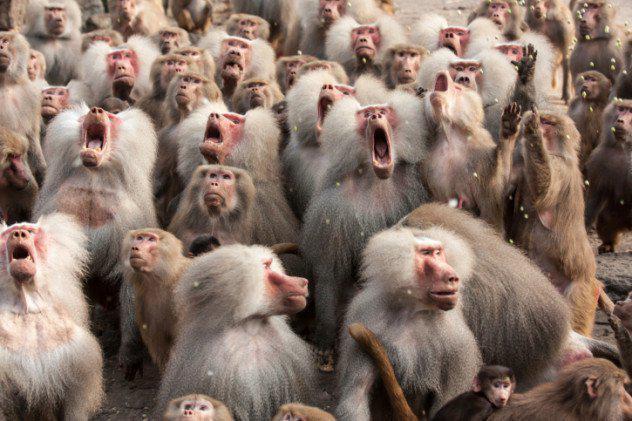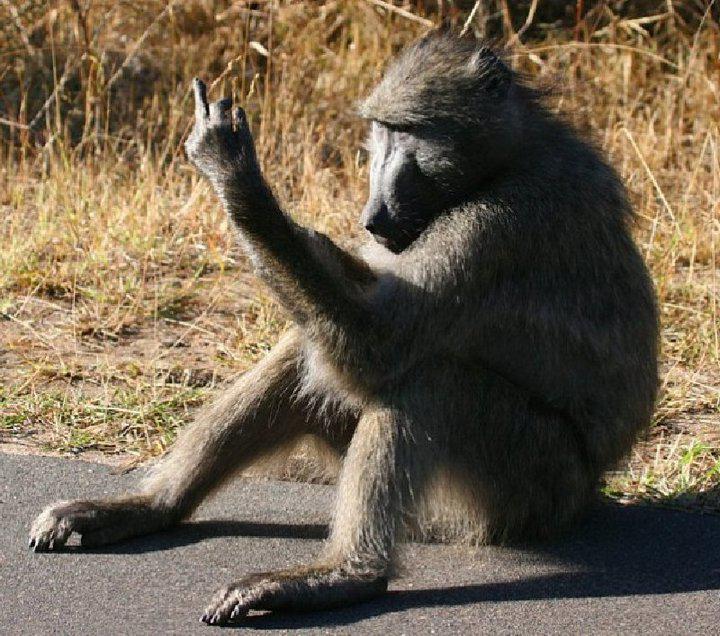The first image is the image on the left, the second image is the image on the right. Examine the images to the left and right. Is the description "There are at most two baboons." accurate? Answer yes or no. No. The first image is the image on the left, the second image is the image on the right. Examine the images to the left and right. Is the description "There are at most two baboons." accurate? Answer yes or no. No. 